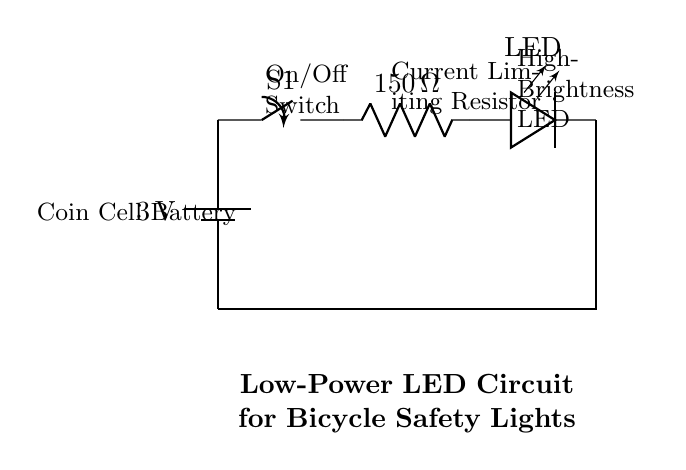What is the voltage of the battery? The voltage is 3 volts, which is indicated next to the battery symbol in the circuit diagram.
Answer: 3 volts What component is used for limiting current? The current limiting resistor is the component labeled as "150 ohm," shown in the circuit diagram.
Answer: 150 ohm How many components are in this circuit? The circuit includes four components: a battery, a switch, a resistor, and an LED, which can be counted visually in the diagram.
Answer: Four What type of LED is used? The circuit diagram specifies a high-brightness LED as indicated next to the LED symbol.
Answer: High-Brightness LED What would happen if the switch is open? If the switch (S1) is open, the circuit is incomplete, and no current can flow, preventing the LED from lighting up.
Answer: No current flows What is the purpose of the switch in this circuit? The switch allows the user to control the on/off state of the LED by either completing or breaking the circuit path.
Answer: On/Off control If the resistor value were halved, what effect would it have? Halving the resistor value would increase the current flowing through the LED, which could exceed the LED's rated current and potentially damage it.
Answer: Increased current 